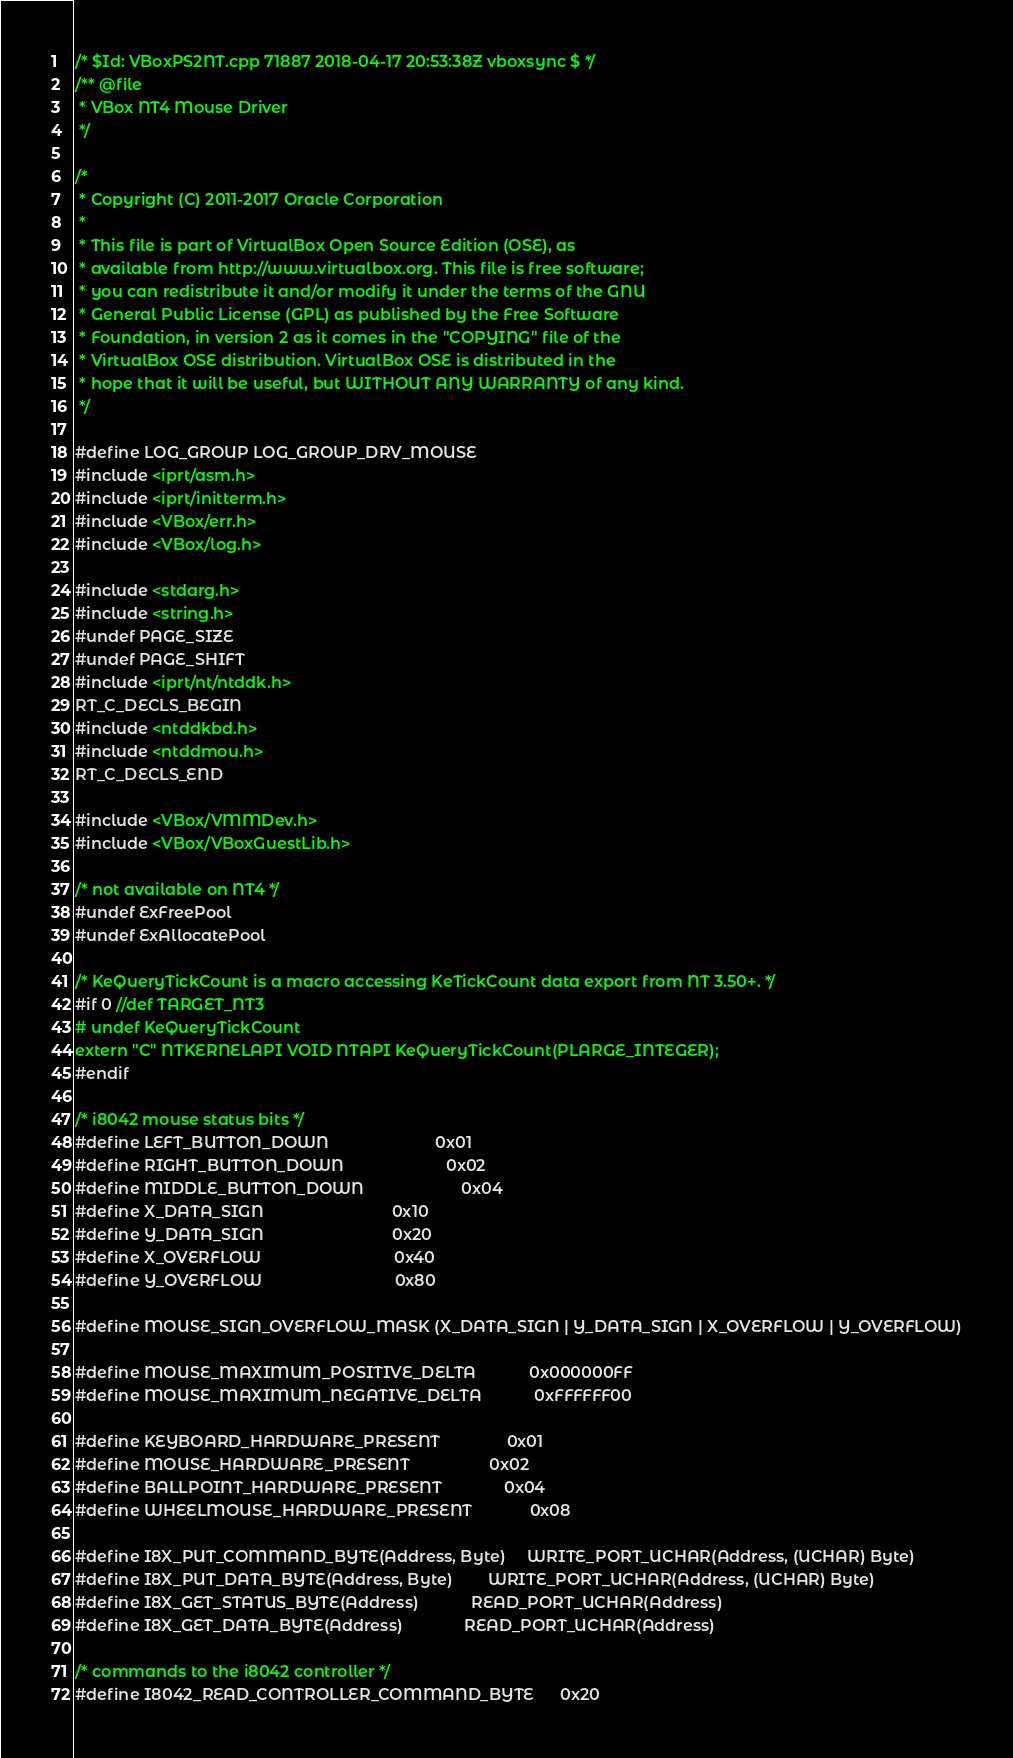<code> <loc_0><loc_0><loc_500><loc_500><_C++_>/* $Id: VBoxPS2NT.cpp 71887 2018-04-17 20:53:38Z vboxsync $ */
/** @file
 * VBox NT4 Mouse Driver
 */

/*
 * Copyright (C) 2011-2017 Oracle Corporation
 *
 * This file is part of VirtualBox Open Source Edition (OSE), as
 * available from http://www.virtualbox.org. This file is free software;
 * you can redistribute it and/or modify it under the terms of the GNU
 * General Public License (GPL) as published by the Free Software
 * Foundation, in version 2 as it comes in the "COPYING" file of the
 * VirtualBox OSE distribution. VirtualBox OSE is distributed in the
 * hope that it will be useful, but WITHOUT ANY WARRANTY of any kind.
 */

#define LOG_GROUP LOG_GROUP_DRV_MOUSE
#include <iprt/asm.h>
#include <iprt/initterm.h>
#include <VBox/err.h>
#include <VBox/log.h>

#include <stdarg.h>
#include <string.h>
#undef PAGE_SIZE
#undef PAGE_SHIFT
#include <iprt/nt/ntddk.h>
RT_C_DECLS_BEGIN
#include <ntddkbd.h>
#include <ntddmou.h>
RT_C_DECLS_END

#include <VBox/VMMDev.h>
#include <VBox/VBoxGuestLib.h>

/* not available on NT4 */
#undef ExFreePool
#undef ExAllocatePool

/* KeQueryTickCount is a macro accessing KeTickCount data export from NT 3.50+. */
#if 0 //def TARGET_NT3
# undef KeQueryTickCount
extern "C" NTKERNELAPI VOID NTAPI KeQueryTickCount(PLARGE_INTEGER);
#endif

/* i8042 mouse status bits */
#define LEFT_BUTTON_DOWN                        0x01
#define RIGHT_BUTTON_DOWN                       0x02
#define MIDDLE_BUTTON_DOWN                      0x04
#define X_DATA_SIGN                             0x10
#define Y_DATA_SIGN                             0x20
#define X_OVERFLOW                              0x40
#define Y_OVERFLOW                              0x80

#define MOUSE_SIGN_OVERFLOW_MASK (X_DATA_SIGN | Y_DATA_SIGN | X_OVERFLOW | Y_OVERFLOW)

#define MOUSE_MAXIMUM_POSITIVE_DELTA            0x000000FF
#define MOUSE_MAXIMUM_NEGATIVE_DELTA            0xFFFFFF00

#define KEYBOARD_HARDWARE_PRESENT               0x01
#define MOUSE_HARDWARE_PRESENT                  0x02
#define BALLPOINT_HARDWARE_PRESENT              0x04
#define WHEELMOUSE_HARDWARE_PRESENT             0x08

#define I8X_PUT_COMMAND_BYTE(Address, Byte)     WRITE_PORT_UCHAR(Address, (UCHAR) Byte)
#define I8X_PUT_DATA_BYTE(Address, Byte)        WRITE_PORT_UCHAR(Address, (UCHAR) Byte)
#define I8X_GET_STATUS_BYTE(Address)            READ_PORT_UCHAR(Address)
#define I8X_GET_DATA_BYTE(Address)              READ_PORT_UCHAR(Address)

/* commands to the i8042 controller */
#define I8042_READ_CONTROLLER_COMMAND_BYTE      0x20</code> 